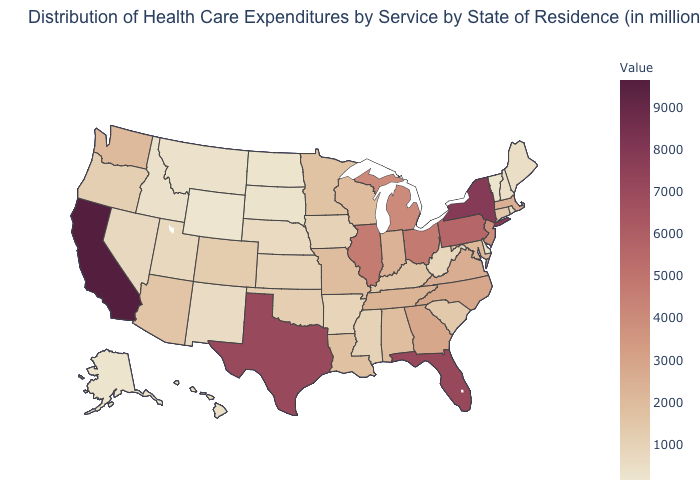Is the legend a continuous bar?
Quick response, please. Yes. Among the states that border Maryland , which have the lowest value?
Keep it brief. Delaware. Is the legend a continuous bar?
Short answer required. Yes. Which states have the highest value in the USA?
Be succinct. California. 